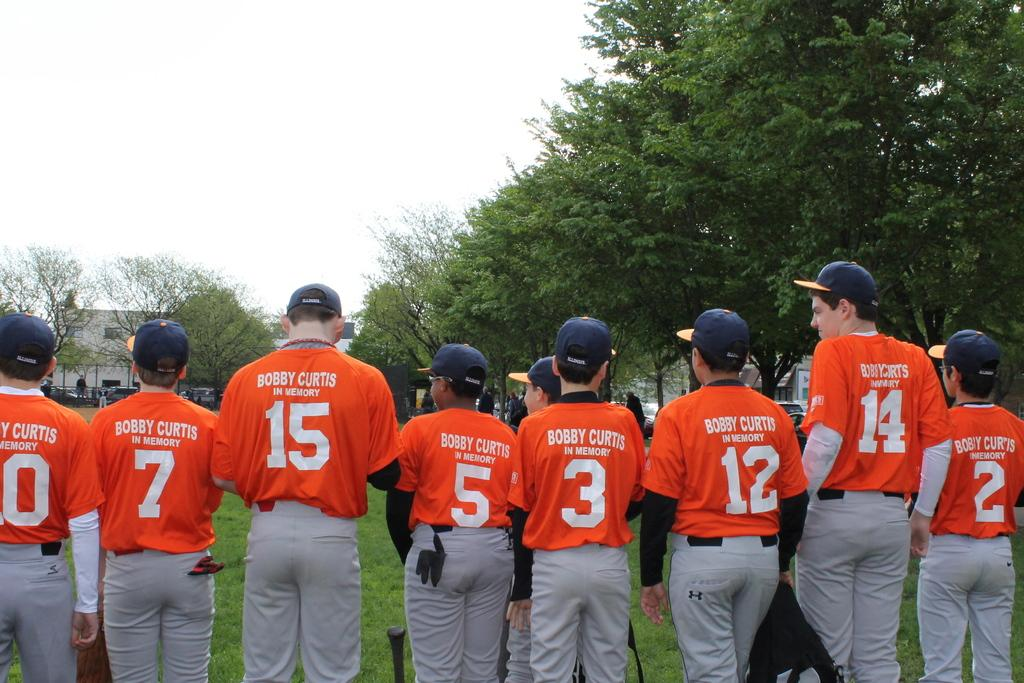Provide a one-sentence caption for the provided image. Several baseball players wear orange jerseys that are in memory of Bobby Curtis. 